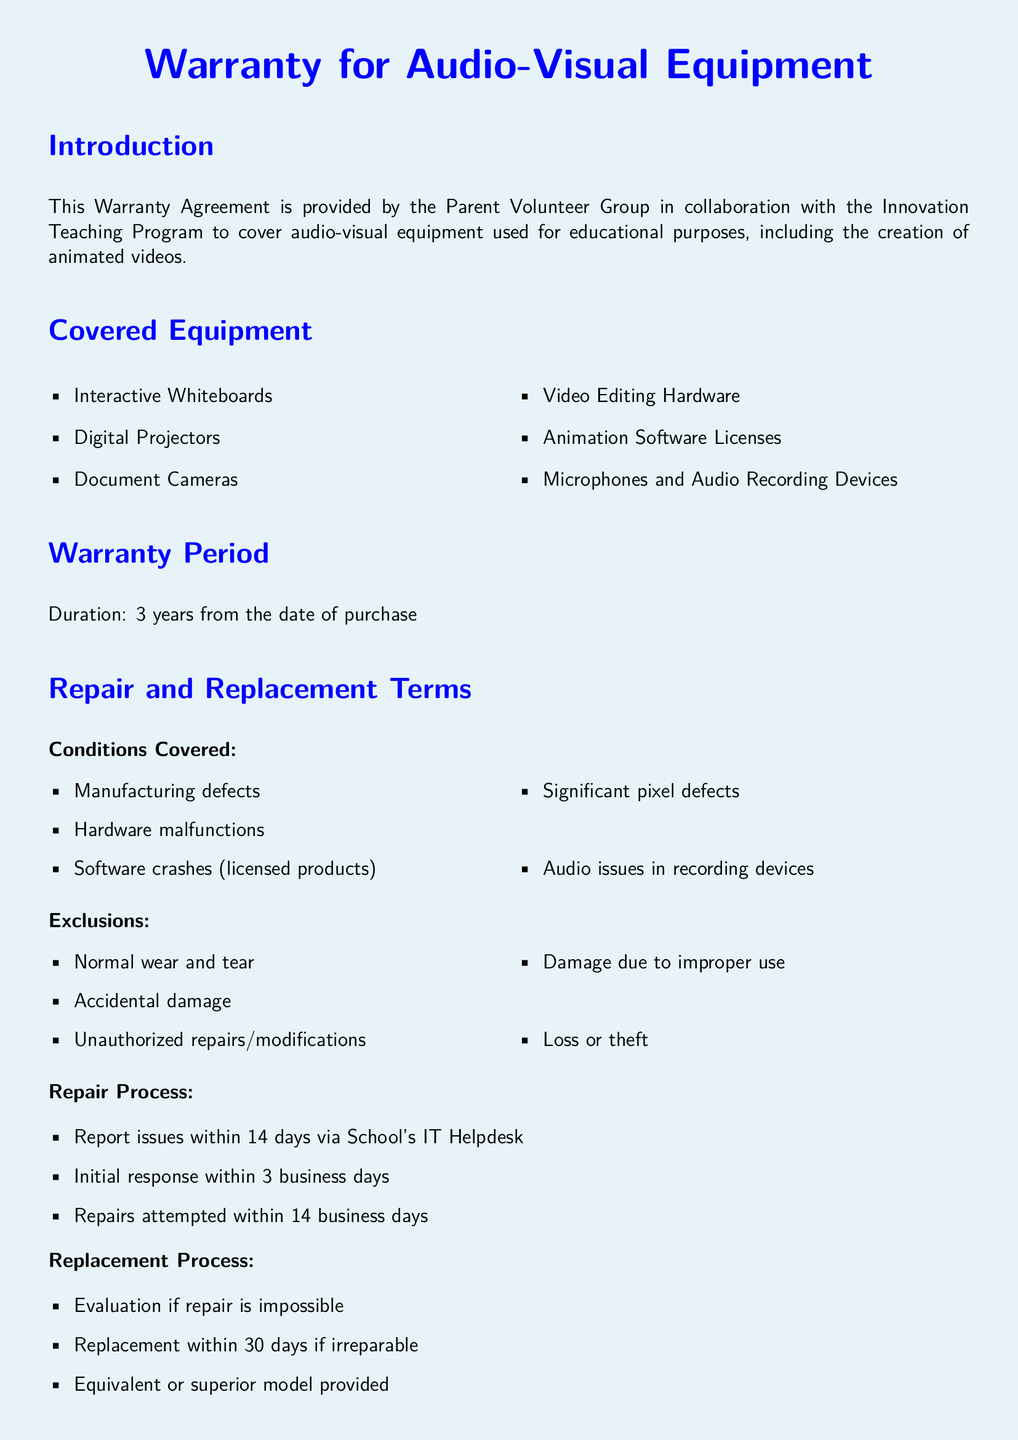What is the warranty period? The warranty period is specified in the document as three years from the date of purchase.
Answer: 3 years Which equipment is included for coverage? The document lists several types of equipment, including interactive whiteboards and digital projectors.
Answer: Interactive Whiteboards, Digital Projectors What conditions are covered under this warranty? The document enumerates conditions like manufacturing defects and hardware malfunctions for coverage.
Answer: Manufacturing defects, Hardware malfunctions How long do you have to report issues? The document specifies a time frame for reporting issues, which is within 14 days.
Answer: 14 days What is the replacement time frame if repair is impossible? The document indicates the replacement process timeframe that is specified for a situation where repair cannot be performed.
Answer: 30 days What is excluded from the warranty coverage? The document outlines exclusions which include normal wear and tear and accidental damage.
Answer: Normal wear and tear, Accidental damage Who should be contacted for technical support? The document provides a specific email address and phone number for technical support inquiries.
Answer: warrantyclaims@school.edu, +1-800-987-6543 What type of warranty is this document classified as? Based on its content, the document can be categorized as a warranty agreement for audio-visual equipment.
Answer: Warranty Agreement What department manages this warranty? The document specifies which department handles the warranty claims and support for the equipment.
Answer: Educational Innovations Department 